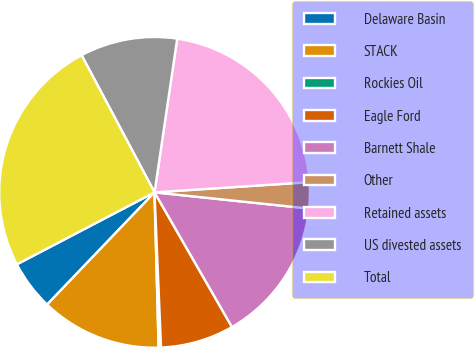Convert chart. <chart><loc_0><loc_0><loc_500><loc_500><pie_chart><fcel>Delaware Basin<fcel>STACK<fcel>Rockies Oil<fcel>Eagle Ford<fcel>Barnett Shale<fcel>Other<fcel>Retained assets<fcel>US divested assets<fcel>Total<nl><fcel>5.18%<fcel>12.57%<fcel>0.25%<fcel>7.64%<fcel>15.03%<fcel>2.71%<fcel>21.62%<fcel>10.11%<fcel>24.89%<nl></chart> 